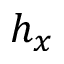<formula> <loc_0><loc_0><loc_500><loc_500>h _ { x }</formula> 